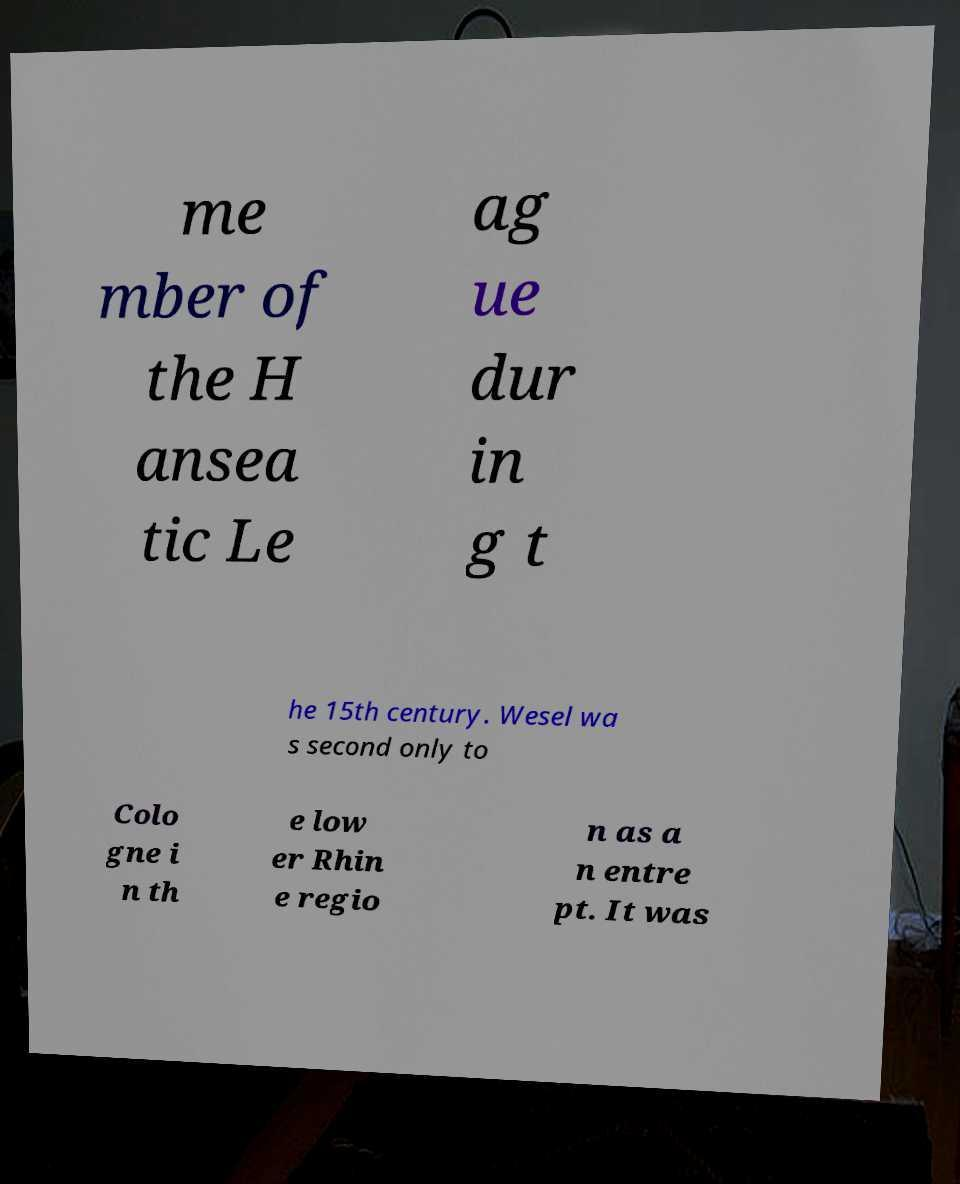Please identify and transcribe the text found in this image. me mber of the H ansea tic Le ag ue dur in g t he 15th century. Wesel wa s second only to Colo gne i n th e low er Rhin e regio n as a n entre pt. It was 